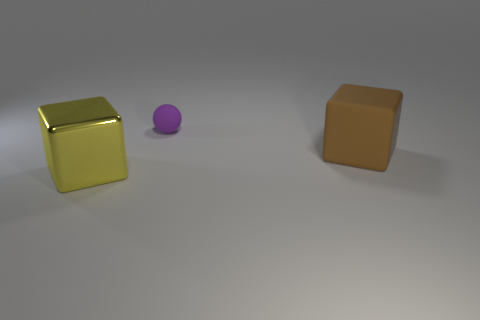Is there any other thing that is the same size as the sphere?
Provide a succinct answer. No. Is there a shiny object of the same color as the sphere?
Provide a succinct answer. No. There is a object that is on the left side of the brown object and behind the big shiny object; what shape is it?
Your answer should be very brief. Sphere. There is a large object right of the large shiny object left of the small object; what shape is it?
Provide a succinct answer. Cube. Is the big brown rubber object the same shape as the tiny purple matte thing?
Give a very brief answer. No. Does the rubber block have the same color as the ball?
Provide a short and direct response. No. There is a block behind the large block that is in front of the large rubber object; what number of big shiny blocks are behind it?
Provide a short and direct response. 0. There is a thing that is the same material as the purple sphere; what shape is it?
Provide a succinct answer. Cube. What is the material of the small purple sphere behind the big object that is to the left of the block that is to the right of the purple object?
Provide a short and direct response. Rubber. What number of objects are either brown rubber blocks that are on the right side of the purple ball or big blue metal cylinders?
Offer a terse response. 1. 